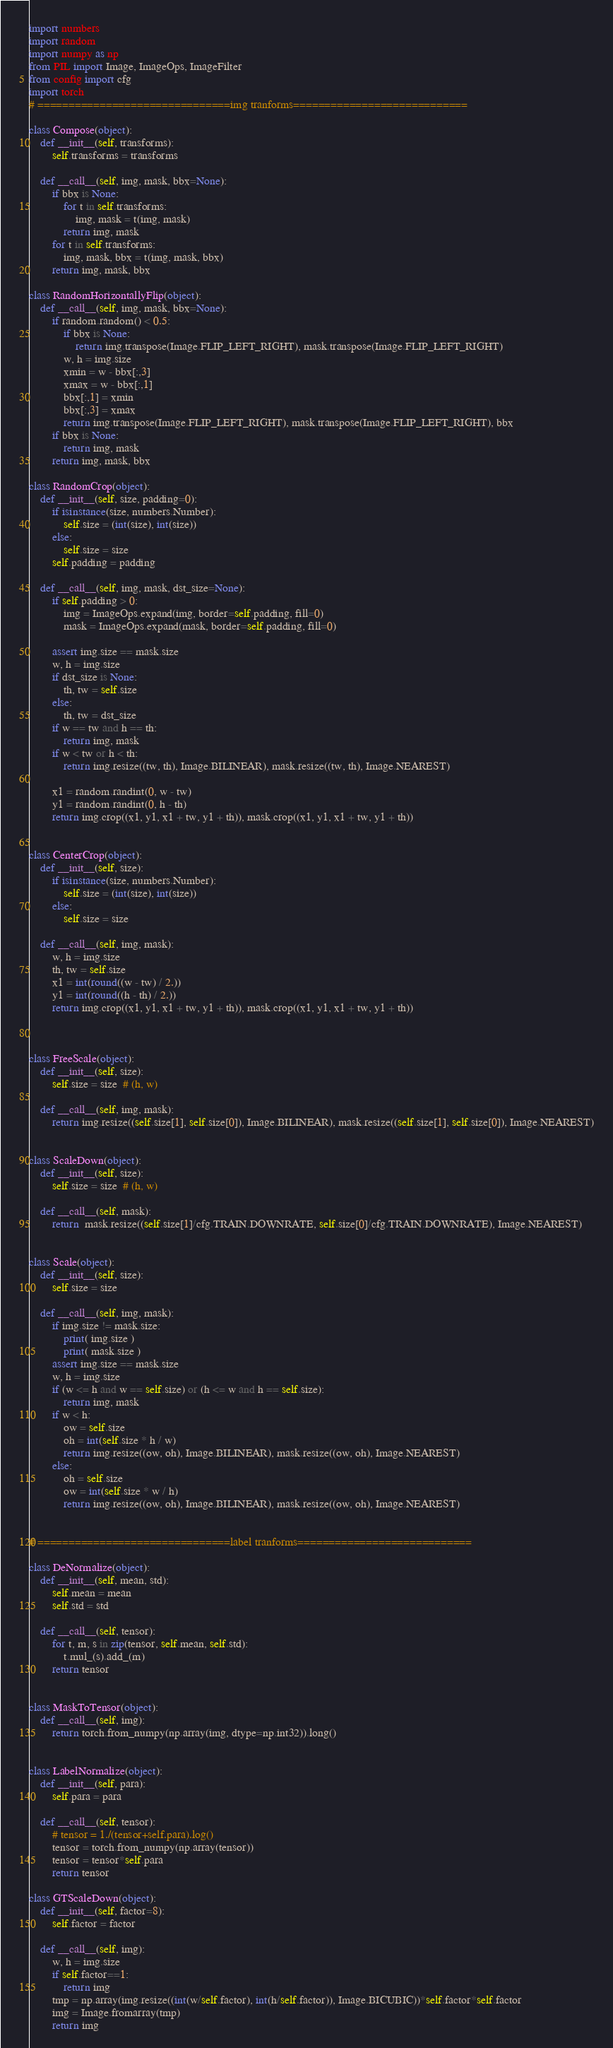Convert code to text. <code><loc_0><loc_0><loc_500><loc_500><_Python_>import numbers
import random
import numpy as np
from PIL import Image, ImageOps, ImageFilter
from config import cfg
import torch
# ===============================img tranforms============================

class Compose(object):
    def __init__(self, transforms):
        self.transforms = transforms

    def __call__(self, img, mask, bbx=None):
        if bbx is None:
            for t in self.transforms:
                img, mask = t(img, mask)
            return img, mask
        for t in self.transforms:
            img, mask, bbx = t(img, mask, bbx)
        return img, mask, bbx

class RandomHorizontallyFlip(object):
    def __call__(self, img, mask, bbx=None):
        if random.random() < 0.5:
            if bbx is None:
                return img.transpose(Image.FLIP_LEFT_RIGHT), mask.transpose(Image.FLIP_LEFT_RIGHT)
            w, h = img.size
            xmin = w - bbx[:,3]
            xmax = w - bbx[:,1]
            bbx[:,1] = xmin
            bbx[:,3] = xmax
            return img.transpose(Image.FLIP_LEFT_RIGHT), mask.transpose(Image.FLIP_LEFT_RIGHT), bbx
        if bbx is None:
            return img, mask
        return img, mask, bbx

class RandomCrop(object):
    def __init__(self, size, padding=0):
        if isinstance(size, numbers.Number):
            self.size = (int(size), int(size))
        else:
            self.size = size
        self.padding = padding

    def __call__(self, img, mask, dst_size=None):
        if self.padding > 0:
            img = ImageOps.expand(img, border=self.padding, fill=0)
            mask = ImageOps.expand(mask, border=self.padding, fill=0)

        assert img.size == mask.size
        w, h = img.size
        if dst_size is None:
            th, tw = self.size
        else:
            th, tw = dst_size
        if w == tw and h == th:
            return img, mask
        if w < tw or h < th:
            return img.resize((tw, th), Image.BILINEAR), mask.resize((tw, th), Image.NEAREST)

        x1 = random.randint(0, w - tw)
        y1 = random.randint(0, h - th)
        return img.crop((x1, y1, x1 + tw, y1 + th)), mask.crop((x1, y1, x1 + tw, y1 + th))


class CenterCrop(object):
    def __init__(self, size):
        if isinstance(size, numbers.Number):
            self.size = (int(size), int(size))
        else:
            self.size = size

    def __call__(self, img, mask):
        w, h = img.size
        th, tw = self.size
        x1 = int(round((w - tw) / 2.))
        y1 = int(round((h - th) / 2.))
        return img.crop((x1, y1, x1 + tw, y1 + th)), mask.crop((x1, y1, x1 + tw, y1 + th))



class FreeScale(object):
    def __init__(self, size):
        self.size = size  # (h, w)

    def __call__(self, img, mask):
        return img.resize((self.size[1], self.size[0]), Image.BILINEAR), mask.resize((self.size[1], self.size[0]), Image.NEAREST)


class ScaleDown(object):
    def __init__(self, size):
        self.size = size  # (h, w)

    def __call__(self, mask):
        return  mask.resize((self.size[1]/cfg.TRAIN.DOWNRATE, self.size[0]/cfg.TRAIN.DOWNRATE), Image.NEAREST)


class Scale(object):
    def __init__(self, size):
        self.size = size

    def __call__(self, img, mask):
        if img.size != mask.size:
            print( img.size )
            print( mask.size )          
        assert img.size == mask.size
        w, h = img.size
        if (w <= h and w == self.size) or (h <= w and h == self.size):
            return img, mask
        if w < h:
            ow = self.size
            oh = int(self.size * h / w)
            return img.resize((ow, oh), Image.BILINEAR), mask.resize((ow, oh), Image.NEAREST)
        else:
            oh = self.size
            ow = int(self.size * w / h)
            return img.resize((ow, oh), Image.BILINEAR), mask.resize((ow, oh), Image.NEAREST)


# ===============================label tranforms============================

class DeNormalize(object):
    def __init__(self, mean, std):
        self.mean = mean
        self.std = std

    def __call__(self, tensor):
        for t, m, s in zip(tensor, self.mean, self.std):
            t.mul_(s).add_(m)
        return tensor


class MaskToTensor(object):
    def __call__(self, img):
        return torch.from_numpy(np.array(img, dtype=np.int32)).long()


class LabelNormalize(object):
    def __init__(self, para):
        self.para = para

    def __call__(self, tensor):
        # tensor = 1./(tensor+self.para).log()
        tensor = torch.from_numpy(np.array(tensor))
        tensor = tensor*self.para
        return tensor

class GTScaleDown(object):
    def __init__(self, factor=8):
        self.factor = factor

    def __call__(self, img):
        w, h = img.size
        if self.factor==1:
            return img
        tmp = np.array(img.resize((int(w/self.factor), int(h/self.factor)), Image.BICUBIC))*self.factor*self.factor
        img = Image.fromarray(tmp)
        return img
</code> 